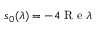<formula> <loc_0><loc_0><loc_500><loc_500>s _ { 0 } ( \lambda ) = - 4 R e \lambda</formula> 